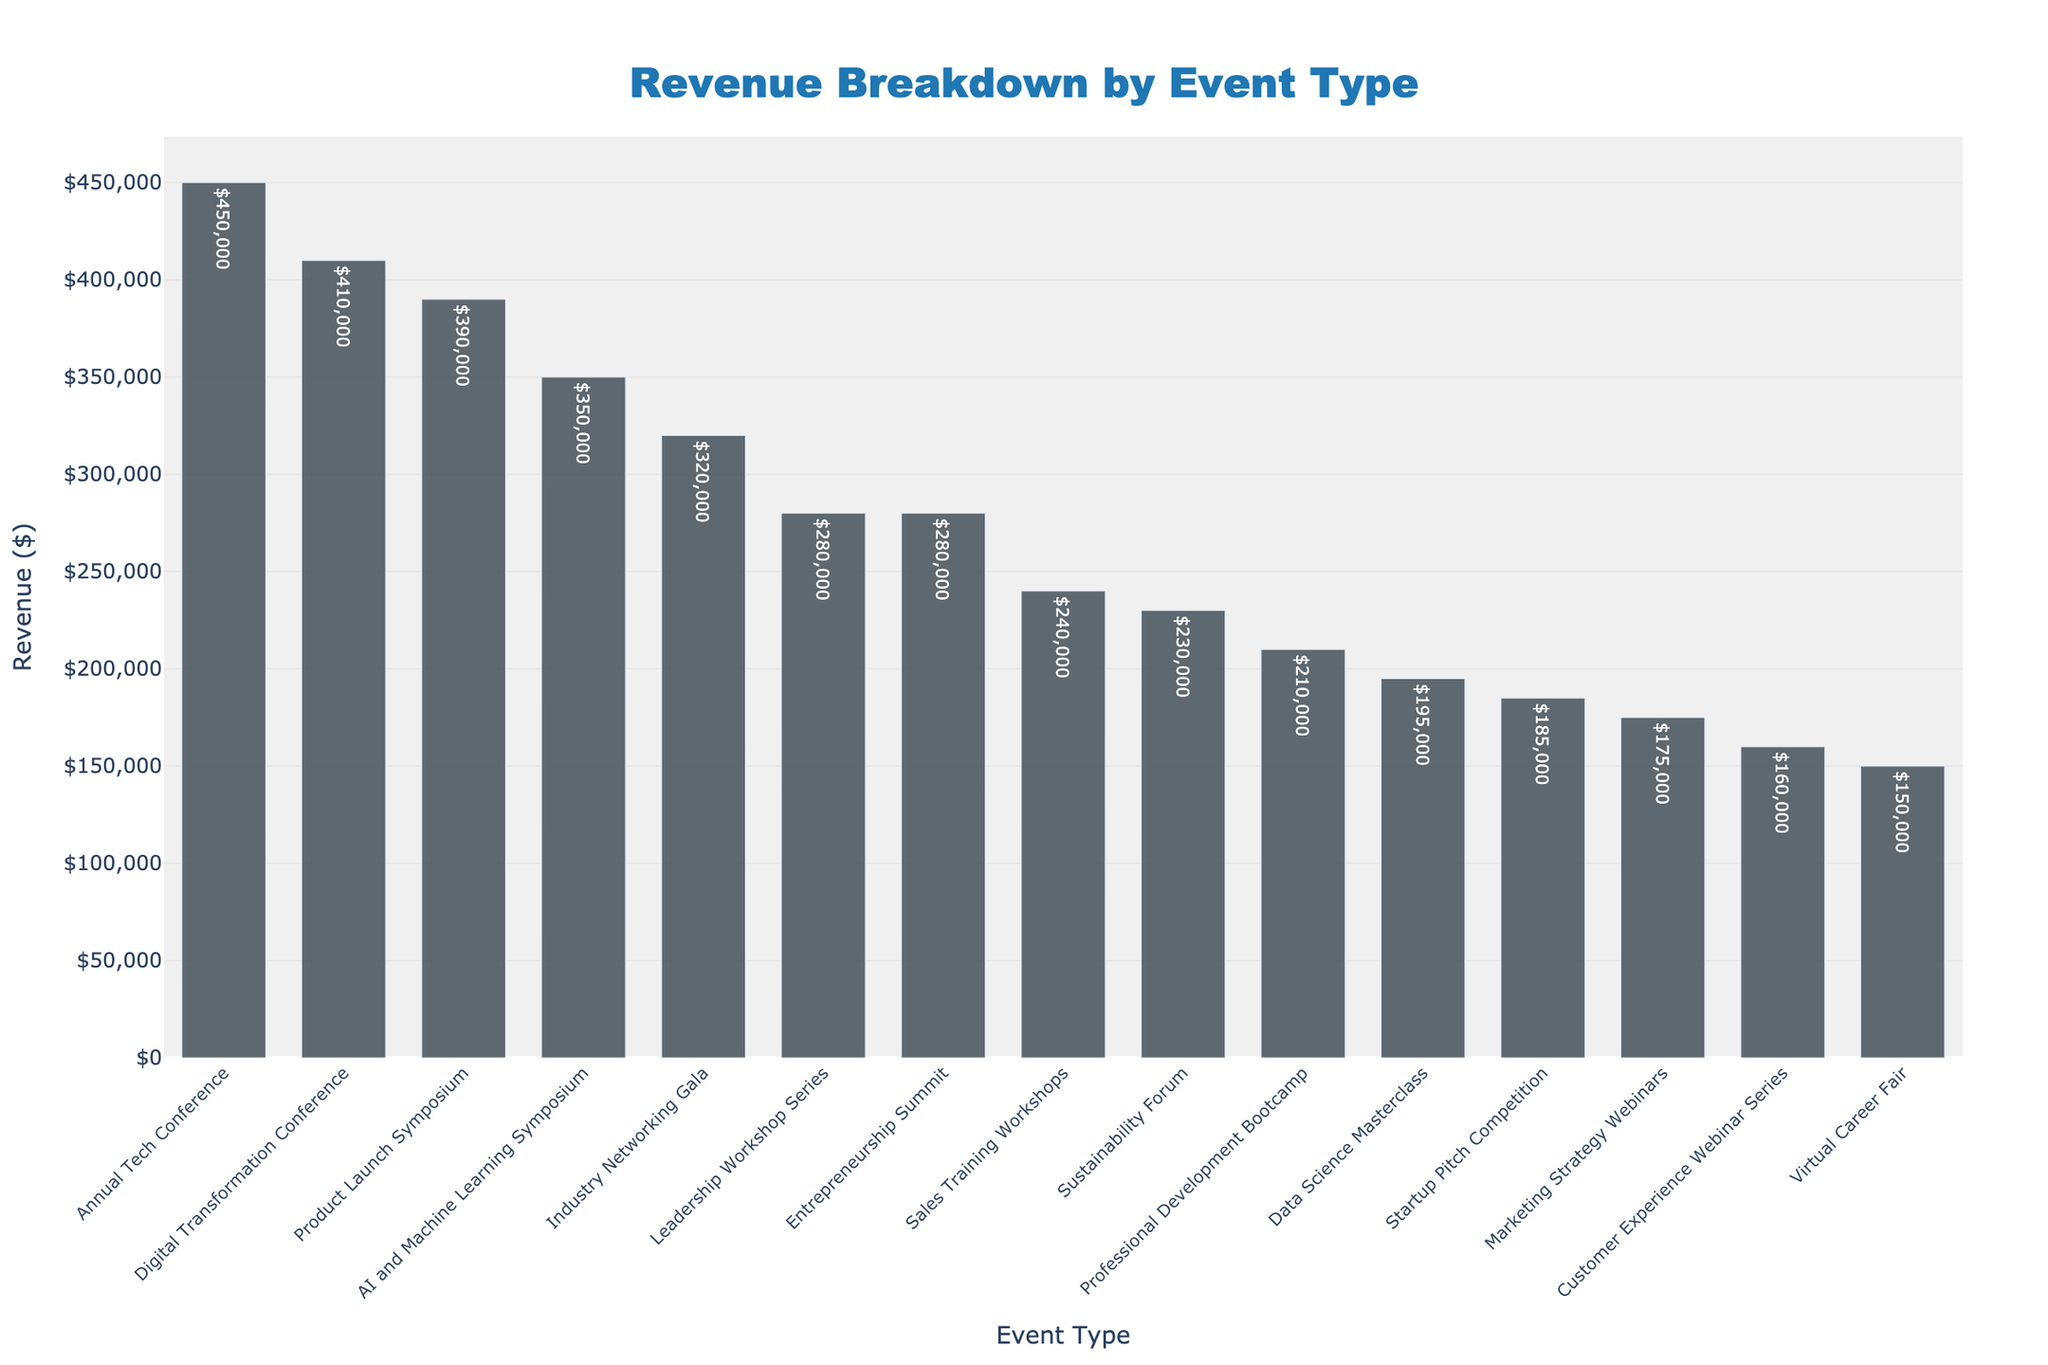What's the highest revenue-generating event type in the chart? The highest revenue-generating event type can be identified by looking for the tallest bar on the chart. The tallest bar corresponds to the "Annual Tech Conference," with revenue of $450,000.
Answer: Annual Tech Conference What are the total revenues generated by Webinars in the chart? To find the total revenue for Webinars, sum the revenues of "Marketing Strategy Webinars," "Customer Experience Webinar Series," and "Virtual Career Fair." The revenues are $175,000, $160,000, and $150,000 respectively. Therefore, the total is $175,000 + $160,000 + $150,000 = $485,000.
Answer: $485,000 Which event type generated less revenue, 'Product Launch Symposium' or 'AI and Machine Learning Symposium'? The bar heights for "Product Launch Symposium" and "AI and Machine Learning Symposium" need to be compared. The "Product Launch Symposium" generated $390,000 while the "AI and Machine Learning Symposium" generated $350,000. Therefore, "AI and Machine Learning Symposium" generated less revenue.
Answer: AI and Machine Learning Symposium What is the combined revenue of the two lowest revenue-generating event types? Identify the two shortest bars on the chart, which are "Virtual Career Fair" and "Customer Experience Webinar Series," with revenues of $150,000 and $160,000 respectively. Add these values: $150,000 + $160,000 = $310,000.
Answer: $310,000 How much more revenue does the "Annual Tech Conference" generate compared to the "Data Science Masterclass"? Locate the bar heights for "Annual Tech Conference" ($450,000) and "Data Science Masterclass" ($195,000), and subtract the latter from the former: $450,000 - $195,000 = $255,000.
Answer: $255,000 What's the revenue difference between the highest and lowest revenue-generating event types in the chart? To find this, subtract the revenue of the lowest revenue-generating event ("Virtual Career Fair" with $150,000) from the highest revenue-generating event ("Annual Tech Conference" with $450,000): $450,000 - $150,000 = $300,000.
Answer: $300,000 How many event types generated revenue greater than $300,000? Count the bars that have heights corresponding to revenues greater than $300,000. There are "Annual Tech Conference," "Digital Transformation Conference," "Product Launch Symposium," "AI and Machine Learning Symposium," and "Industry Networking Gala," making it 5 event types.
Answer: 5 Which event type is directly in the middle of the sorted revenue list? For this, list all events sorted by revenue: starting from the highest to the lowest. The middle value (8th event in a list of 15) corresponds to "Sustainability Forum" with a revenue of $230,000.
Answer: Sustainability Forum 